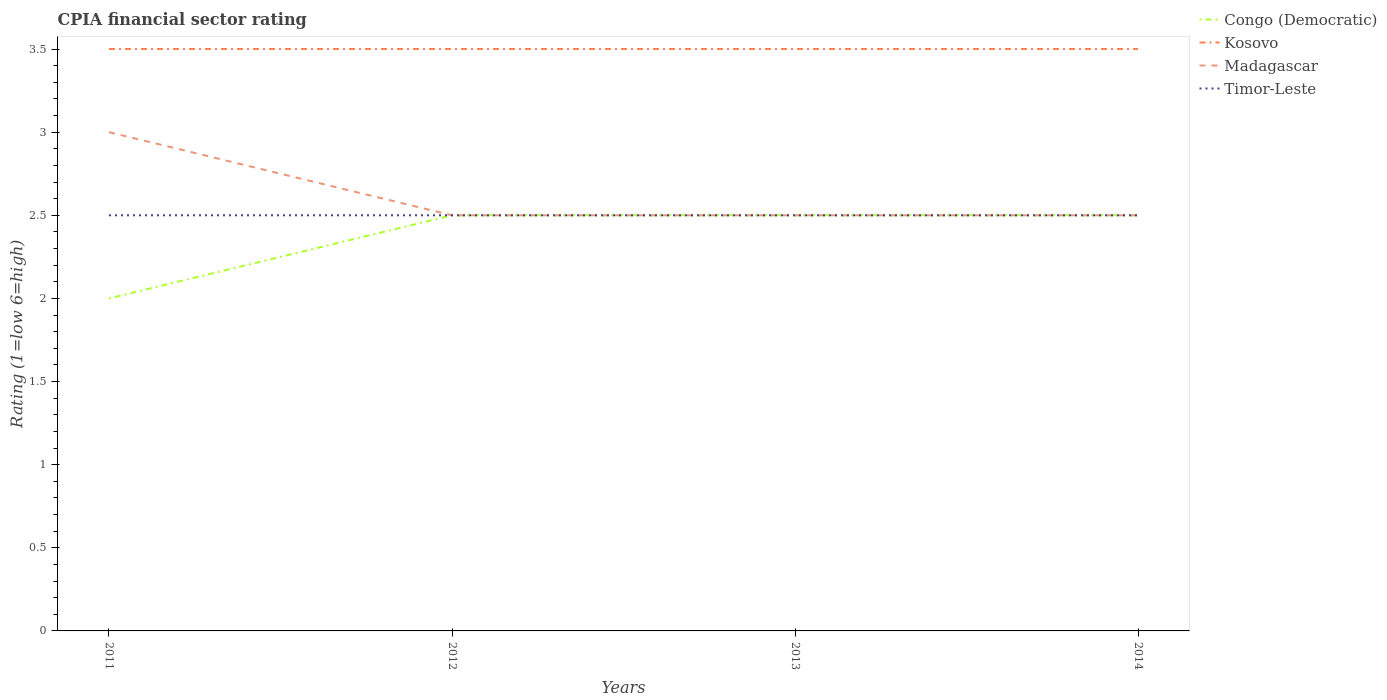Does the line corresponding to Madagascar intersect with the line corresponding to Timor-Leste?
Make the answer very short. Yes. Across all years, what is the maximum CPIA rating in Madagascar?
Offer a very short reply. 2.5. What is the total CPIA rating in Kosovo in the graph?
Provide a succinct answer. 0. What is the difference between the highest and the lowest CPIA rating in Kosovo?
Your answer should be very brief. 0. Are the values on the major ticks of Y-axis written in scientific E-notation?
Ensure brevity in your answer.  No. Does the graph contain any zero values?
Provide a short and direct response. No. Where does the legend appear in the graph?
Keep it short and to the point. Top right. What is the title of the graph?
Provide a succinct answer. CPIA financial sector rating. What is the label or title of the X-axis?
Provide a succinct answer. Years. What is the Rating (1=low 6=high) of Madagascar in 2011?
Keep it short and to the point. 3. What is the Rating (1=low 6=high) of Timor-Leste in 2011?
Give a very brief answer. 2.5. What is the Rating (1=low 6=high) in Congo (Democratic) in 2013?
Give a very brief answer. 2.5. What is the Rating (1=low 6=high) in Congo (Democratic) in 2014?
Give a very brief answer. 2.5. What is the Rating (1=low 6=high) in Kosovo in 2014?
Offer a terse response. 3.5. What is the Rating (1=low 6=high) of Madagascar in 2014?
Offer a terse response. 2.5. What is the Rating (1=low 6=high) of Timor-Leste in 2014?
Make the answer very short. 2.5. Across all years, what is the maximum Rating (1=low 6=high) in Congo (Democratic)?
Your answer should be compact. 2.5. Across all years, what is the maximum Rating (1=low 6=high) in Kosovo?
Make the answer very short. 3.5. Across all years, what is the maximum Rating (1=low 6=high) of Timor-Leste?
Give a very brief answer. 2.5. Across all years, what is the minimum Rating (1=low 6=high) in Congo (Democratic)?
Provide a succinct answer. 2. Across all years, what is the minimum Rating (1=low 6=high) of Kosovo?
Provide a succinct answer. 3.5. Across all years, what is the minimum Rating (1=low 6=high) in Timor-Leste?
Ensure brevity in your answer.  2.5. What is the total Rating (1=low 6=high) of Madagascar in the graph?
Make the answer very short. 10.5. What is the total Rating (1=low 6=high) of Timor-Leste in the graph?
Make the answer very short. 10. What is the difference between the Rating (1=low 6=high) in Kosovo in 2011 and that in 2012?
Make the answer very short. 0. What is the difference between the Rating (1=low 6=high) in Congo (Democratic) in 2011 and that in 2013?
Provide a succinct answer. -0.5. What is the difference between the Rating (1=low 6=high) in Kosovo in 2011 and that in 2013?
Your response must be concise. 0. What is the difference between the Rating (1=low 6=high) of Timor-Leste in 2011 and that in 2013?
Make the answer very short. 0. What is the difference between the Rating (1=low 6=high) of Congo (Democratic) in 2011 and that in 2014?
Your answer should be very brief. -0.5. What is the difference between the Rating (1=low 6=high) in Timor-Leste in 2011 and that in 2014?
Provide a succinct answer. 0. What is the difference between the Rating (1=low 6=high) in Kosovo in 2012 and that in 2013?
Provide a short and direct response. 0. What is the difference between the Rating (1=low 6=high) in Timor-Leste in 2012 and that in 2013?
Offer a terse response. 0. What is the difference between the Rating (1=low 6=high) of Kosovo in 2012 and that in 2014?
Your answer should be compact. 0. What is the difference between the Rating (1=low 6=high) in Congo (Democratic) in 2013 and that in 2014?
Your answer should be compact. 0. What is the difference between the Rating (1=low 6=high) in Kosovo in 2013 and that in 2014?
Offer a very short reply. 0. What is the difference between the Rating (1=low 6=high) in Madagascar in 2013 and that in 2014?
Ensure brevity in your answer.  0. What is the difference between the Rating (1=low 6=high) in Timor-Leste in 2013 and that in 2014?
Your response must be concise. 0. What is the difference between the Rating (1=low 6=high) of Congo (Democratic) in 2011 and the Rating (1=low 6=high) of Kosovo in 2012?
Provide a succinct answer. -1.5. What is the difference between the Rating (1=low 6=high) in Kosovo in 2011 and the Rating (1=low 6=high) in Madagascar in 2012?
Give a very brief answer. 1. What is the difference between the Rating (1=low 6=high) in Kosovo in 2011 and the Rating (1=low 6=high) in Timor-Leste in 2012?
Make the answer very short. 1. What is the difference between the Rating (1=low 6=high) of Congo (Democratic) in 2011 and the Rating (1=low 6=high) of Kosovo in 2013?
Your answer should be compact. -1.5. What is the difference between the Rating (1=low 6=high) of Congo (Democratic) in 2011 and the Rating (1=low 6=high) of Madagascar in 2013?
Offer a very short reply. -0.5. What is the difference between the Rating (1=low 6=high) in Kosovo in 2011 and the Rating (1=low 6=high) in Madagascar in 2013?
Offer a very short reply. 1. What is the difference between the Rating (1=low 6=high) in Kosovo in 2011 and the Rating (1=low 6=high) in Timor-Leste in 2013?
Your answer should be very brief. 1. What is the difference between the Rating (1=low 6=high) of Congo (Democratic) in 2011 and the Rating (1=low 6=high) of Timor-Leste in 2014?
Your response must be concise. -0.5. What is the difference between the Rating (1=low 6=high) in Kosovo in 2011 and the Rating (1=low 6=high) in Timor-Leste in 2014?
Your answer should be compact. 1. What is the difference between the Rating (1=low 6=high) in Congo (Democratic) in 2012 and the Rating (1=low 6=high) in Madagascar in 2013?
Provide a succinct answer. 0. What is the difference between the Rating (1=low 6=high) of Congo (Democratic) in 2012 and the Rating (1=low 6=high) of Timor-Leste in 2013?
Your answer should be very brief. 0. What is the difference between the Rating (1=low 6=high) in Kosovo in 2012 and the Rating (1=low 6=high) in Madagascar in 2013?
Provide a short and direct response. 1. What is the difference between the Rating (1=low 6=high) of Congo (Democratic) in 2012 and the Rating (1=low 6=high) of Kosovo in 2014?
Keep it short and to the point. -1. What is the difference between the Rating (1=low 6=high) in Congo (Democratic) in 2012 and the Rating (1=low 6=high) in Timor-Leste in 2014?
Your answer should be compact. 0. What is the difference between the Rating (1=low 6=high) of Kosovo in 2012 and the Rating (1=low 6=high) of Timor-Leste in 2014?
Offer a terse response. 1. What is the difference between the Rating (1=low 6=high) of Congo (Democratic) in 2013 and the Rating (1=low 6=high) of Kosovo in 2014?
Your answer should be compact. -1. What is the difference between the Rating (1=low 6=high) of Kosovo in 2013 and the Rating (1=low 6=high) of Madagascar in 2014?
Ensure brevity in your answer.  1. What is the difference between the Rating (1=low 6=high) in Madagascar in 2013 and the Rating (1=low 6=high) in Timor-Leste in 2014?
Provide a short and direct response. 0. What is the average Rating (1=low 6=high) in Congo (Democratic) per year?
Your answer should be very brief. 2.38. What is the average Rating (1=low 6=high) in Kosovo per year?
Make the answer very short. 3.5. What is the average Rating (1=low 6=high) of Madagascar per year?
Provide a succinct answer. 2.62. What is the average Rating (1=low 6=high) of Timor-Leste per year?
Your answer should be very brief. 2.5. In the year 2011, what is the difference between the Rating (1=low 6=high) in Congo (Democratic) and Rating (1=low 6=high) in Kosovo?
Offer a very short reply. -1.5. In the year 2011, what is the difference between the Rating (1=low 6=high) in Congo (Democratic) and Rating (1=low 6=high) in Madagascar?
Provide a short and direct response. -1. In the year 2011, what is the difference between the Rating (1=low 6=high) in Congo (Democratic) and Rating (1=low 6=high) in Timor-Leste?
Keep it short and to the point. -0.5. In the year 2011, what is the difference between the Rating (1=low 6=high) of Madagascar and Rating (1=low 6=high) of Timor-Leste?
Ensure brevity in your answer.  0.5. In the year 2012, what is the difference between the Rating (1=low 6=high) of Congo (Democratic) and Rating (1=low 6=high) of Kosovo?
Ensure brevity in your answer.  -1. In the year 2012, what is the difference between the Rating (1=low 6=high) in Madagascar and Rating (1=low 6=high) in Timor-Leste?
Offer a terse response. 0. In the year 2013, what is the difference between the Rating (1=low 6=high) in Congo (Democratic) and Rating (1=low 6=high) in Kosovo?
Provide a succinct answer. -1. In the year 2013, what is the difference between the Rating (1=low 6=high) of Congo (Democratic) and Rating (1=low 6=high) of Madagascar?
Keep it short and to the point. 0. In the year 2013, what is the difference between the Rating (1=low 6=high) in Congo (Democratic) and Rating (1=low 6=high) in Timor-Leste?
Provide a succinct answer. 0. In the year 2013, what is the difference between the Rating (1=low 6=high) in Kosovo and Rating (1=low 6=high) in Madagascar?
Give a very brief answer. 1. In the year 2014, what is the difference between the Rating (1=low 6=high) of Congo (Democratic) and Rating (1=low 6=high) of Timor-Leste?
Ensure brevity in your answer.  0. In the year 2014, what is the difference between the Rating (1=low 6=high) of Kosovo and Rating (1=low 6=high) of Timor-Leste?
Give a very brief answer. 1. What is the ratio of the Rating (1=low 6=high) of Congo (Democratic) in 2011 to that in 2012?
Provide a short and direct response. 0.8. What is the ratio of the Rating (1=low 6=high) of Kosovo in 2011 to that in 2012?
Ensure brevity in your answer.  1. What is the ratio of the Rating (1=low 6=high) of Madagascar in 2011 to that in 2012?
Make the answer very short. 1.2. What is the ratio of the Rating (1=low 6=high) in Timor-Leste in 2011 to that in 2012?
Offer a very short reply. 1. What is the ratio of the Rating (1=low 6=high) in Congo (Democratic) in 2011 to that in 2013?
Your answer should be very brief. 0.8. What is the ratio of the Rating (1=low 6=high) of Congo (Democratic) in 2011 to that in 2014?
Provide a short and direct response. 0.8. What is the ratio of the Rating (1=low 6=high) of Kosovo in 2011 to that in 2014?
Offer a very short reply. 1. What is the ratio of the Rating (1=low 6=high) in Madagascar in 2011 to that in 2014?
Offer a terse response. 1.2. What is the ratio of the Rating (1=low 6=high) of Kosovo in 2012 to that in 2013?
Offer a very short reply. 1. What is the ratio of the Rating (1=low 6=high) in Madagascar in 2012 to that in 2013?
Your answer should be compact. 1. What is the ratio of the Rating (1=low 6=high) in Congo (Democratic) in 2012 to that in 2014?
Your answer should be compact. 1. What is the ratio of the Rating (1=low 6=high) in Kosovo in 2012 to that in 2014?
Keep it short and to the point. 1. What is the ratio of the Rating (1=low 6=high) in Timor-Leste in 2012 to that in 2014?
Your response must be concise. 1. What is the ratio of the Rating (1=low 6=high) of Kosovo in 2013 to that in 2014?
Keep it short and to the point. 1. What is the difference between the highest and the second highest Rating (1=low 6=high) of Kosovo?
Offer a terse response. 0. What is the difference between the highest and the lowest Rating (1=low 6=high) in Congo (Democratic)?
Your response must be concise. 0.5. What is the difference between the highest and the lowest Rating (1=low 6=high) in Kosovo?
Offer a terse response. 0. What is the difference between the highest and the lowest Rating (1=low 6=high) of Madagascar?
Make the answer very short. 0.5. What is the difference between the highest and the lowest Rating (1=low 6=high) in Timor-Leste?
Offer a very short reply. 0. 